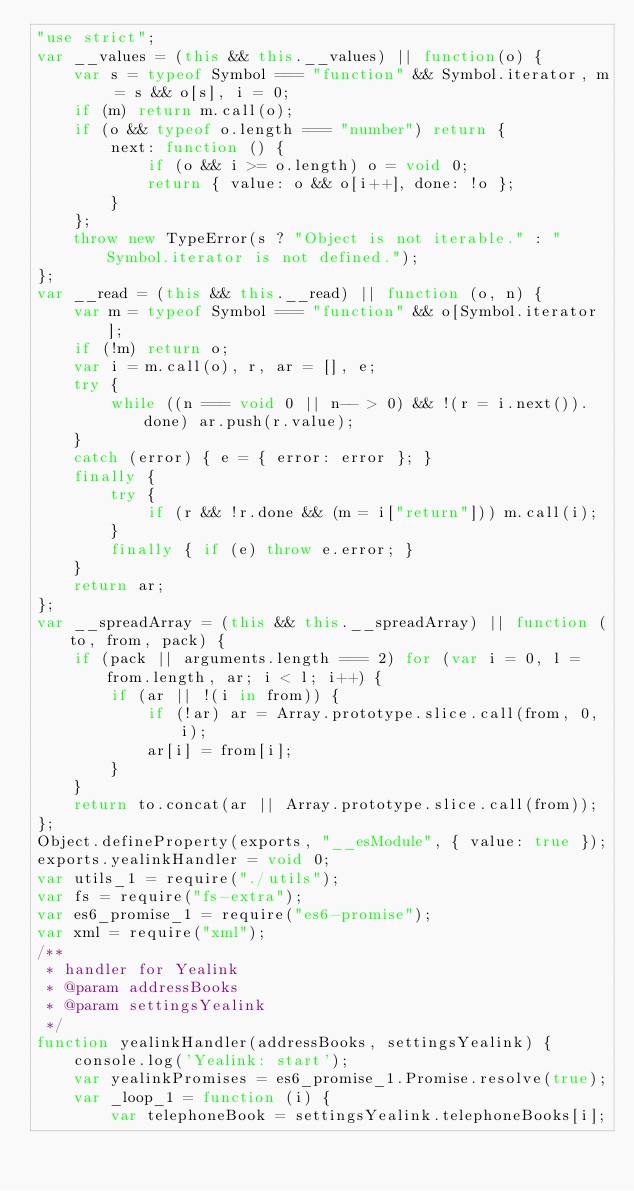Convert code to text. <code><loc_0><loc_0><loc_500><loc_500><_JavaScript_>"use strict";
var __values = (this && this.__values) || function(o) {
    var s = typeof Symbol === "function" && Symbol.iterator, m = s && o[s], i = 0;
    if (m) return m.call(o);
    if (o && typeof o.length === "number") return {
        next: function () {
            if (o && i >= o.length) o = void 0;
            return { value: o && o[i++], done: !o };
        }
    };
    throw new TypeError(s ? "Object is not iterable." : "Symbol.iterator is not defined.");
};
var __read = (this && this.__read) || function (o, n) {
    var m = typeof Symbol === "function" && o[Symbol.iterator];
    if (!m) return o;
    var i = m.call(o), r, ar = [], e;
    try {
        while ((n === void 0 || n-- > 0) && !(r = i.next()).done) ar.push(r.value);
    }
    catch (error) { e = { error: error }; }
    finally {
        try {
            if (r && !r.done && (m = i["return"])) m.call(i);
        }
        finally { if (e) throw e.error; }
    }
    return ar;
};
var __spreadArray = (this && this.__spreadArray) || function (to, from, pack) {
    if (pack || arguments.length === 2) for (var i = 0, l = from.length, ar; i < l; i++) {
        if (ar || !(i in from)) {
            if (!ar) ar = Array.prototype.slice.call(from, 0, i);
            ar[i] = from[i];
        }
    }
    return to.concat(ar || Array.prototype.slice.call(from));
};
Object.defineProperty(exports, "__esModule", { value: true });
exports.yealinkHandler = void 0;
var utils_1 = require("./utils");
var fs = require("fs-extra");
var es6_promise_1 = require("es6-promise");
var xml = require("xml");
/**
 * handler for Yealink
 * @param addressBooks
 * @param settingsYealink
 */
function yealinkHandler(addressBooks, settingsYealink) {
    console.log('Yealink: start');
    var yealinkPromises = es6_promise_1.Promise.resolve(true);
    var _loop_1 = function (i) {
        var telephoneBook = settingsYealink.telephoneBooks[i];</code> 